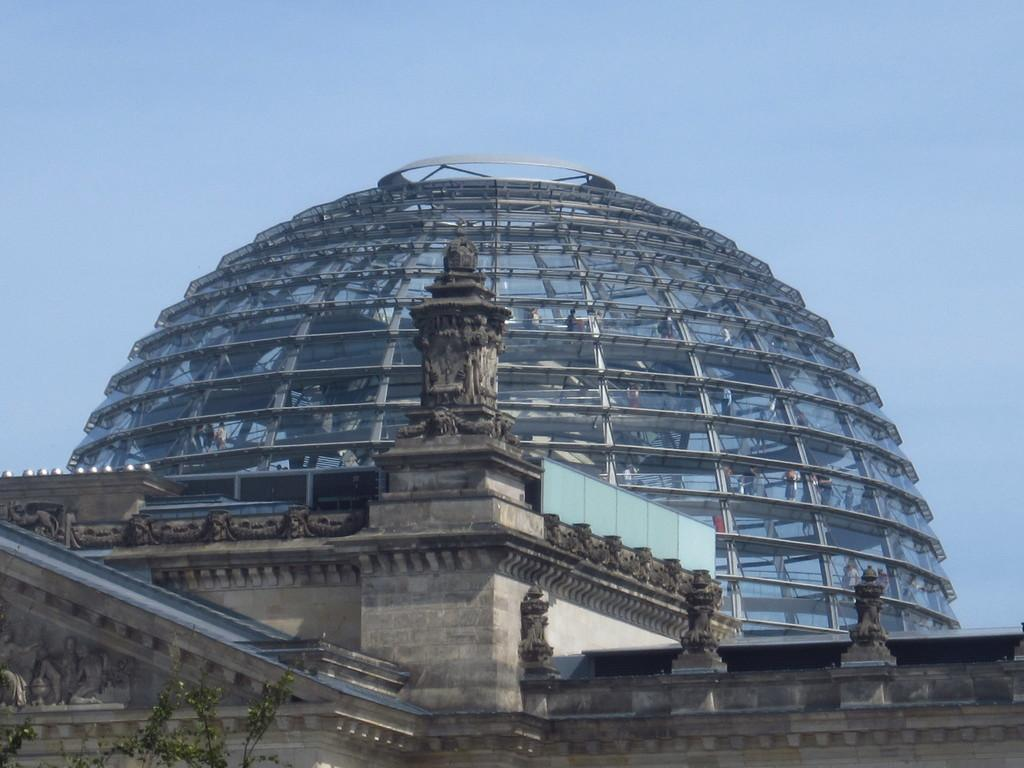What is the color of the building in the image? The building in the image has a grey and white color. What type of material is used for the building in the image? The building in the image is made of glass. What color is the sky in the image? The sky is blue in the image. What type of business is being conducted in the glass building in the image? There is no indication of any business being conducted in the image; it only shows a glass building and a blue sky. What part of the industry does the grey and white building in the image belong to? There is no information about the industry or any specific part of it in the image. 